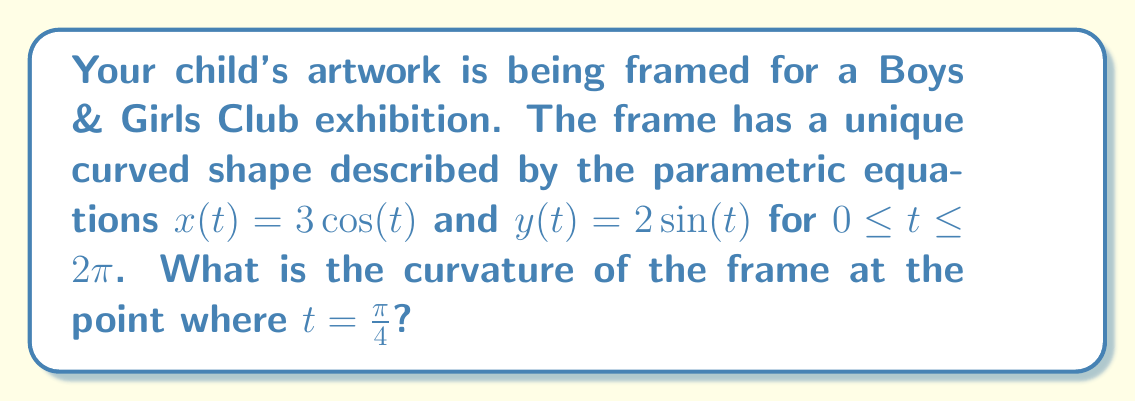Can you solve this math problem? To find the curvature of the frame, we'll use the formula for curvature of a parametric curve:

$$\kappa = \frac{|x'y'' - y'x''|}{(x'^2 + y'^2)^{3/2}}$$

Step 1: Calculate the first derivatives:
$x'(t) = -3\sin(t)$
$y'(t) = 2\cos(t)$

Step 2: Calculate the second derivatives:
$x''(t) = -3\cos(t)$
$y''(t) = -2\sin(t)$

Step 3: Evaluate the derivatives at $t = \frac{\pi}{4}$:
$x'(\frac{\pi}{4}) = -3\sin(\frac{\pi}{4}) = -\frac{3\sqrt{2}}{2}$
$y'(\frac{\pi}{4}) = 2\cos(\frac{\pi}{4}) = \sqrt{2}$
$x''(\frac{\pi}{4}) = -3\cos(\frac{\pi}{4}) = -\frac{3\sqrt{2}}{2}$
$y''(\frac{\pi}{4}) = -2\sin(\frac{\pi}{4}) = -\sqrt{2}$

Step 4: Substitute into the curvature formula:

$$\kappa = \frac{|(-\frac{3\sqrt{2}}{2})(-\sqrt{2}) - (\sqrt{2})(-\frac{3\sqrt{2}}{2})|}{((-\frac{3\sqrt{2}}{2})^2 + (\sqrt{2})^2)^{3/2}}$$

Step 5: Simplify:

$$\kappa = \frac{|3 + 3|}{((\frac{9}{2}) + 2)^{3/2}} = \frac{6}{(\frac{13}{2})^{3/2}} = \frac{6}{(\frac{13}{2})^{3/2}} \cdot \frac{2^{3/2}}{2^{3/2}} = \frac{12\sqrt{2}}{13\sqrt{13}}$$
Answer: $\frac{12\sqrt{2}}{13\sqrt{13}}$ 